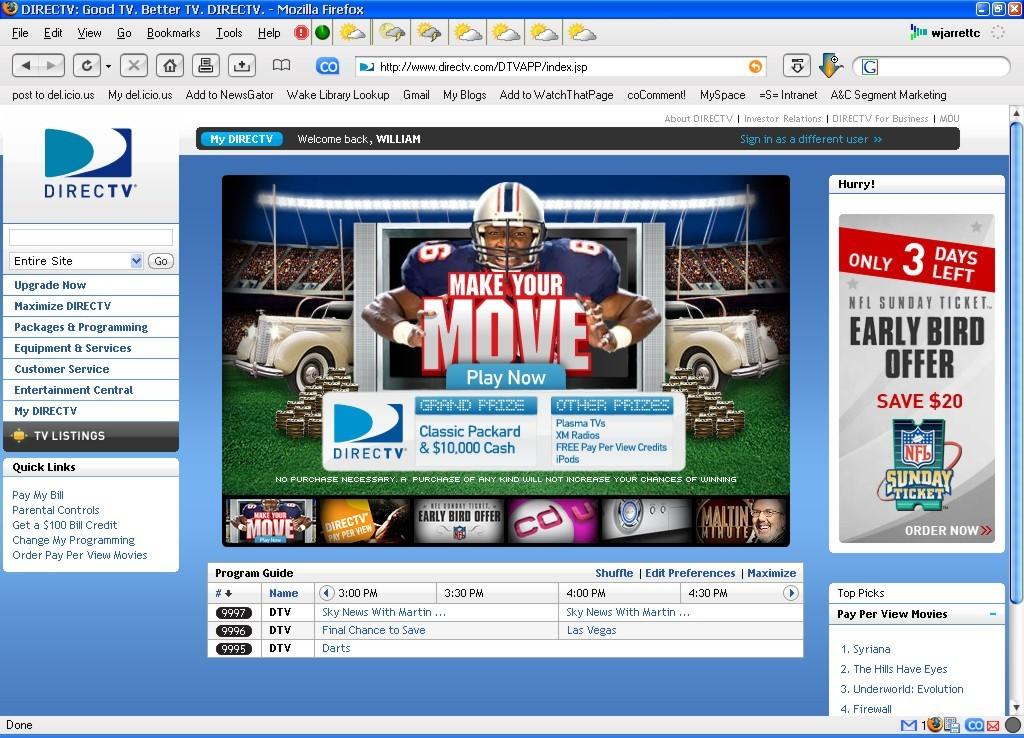What type of image is being shown? The image is a screenshot of a browser. What type of quilt is being displayed on the camp website in the image? There is no website or quilt present in the image; it is a screenshot of a browser. How many trucks are visible on the campgrounds in the image? There are no campgrounds or trucks present in the image; it is a screenshot of a browser. 